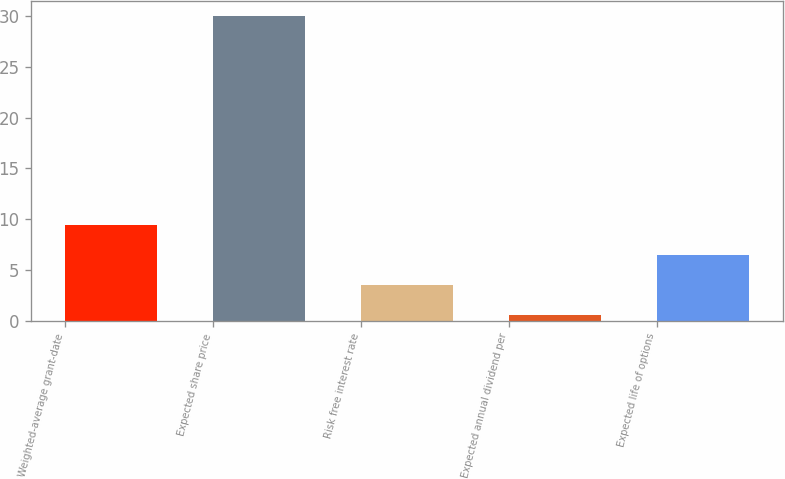Convert chart. <chart><loc_0><loc_0><loc_500><loc_500><bar_chart><fcel>Weighted-average grant-date<fcel>Expected share price<fcel>Risk free interest rate<fcel>Expected annual dividend per<fcel>Expected life of options<nl><fcel>9.41<fcel>30<fcel>3.53<fcel>0.59<fcel>6.47<nl></chart> 